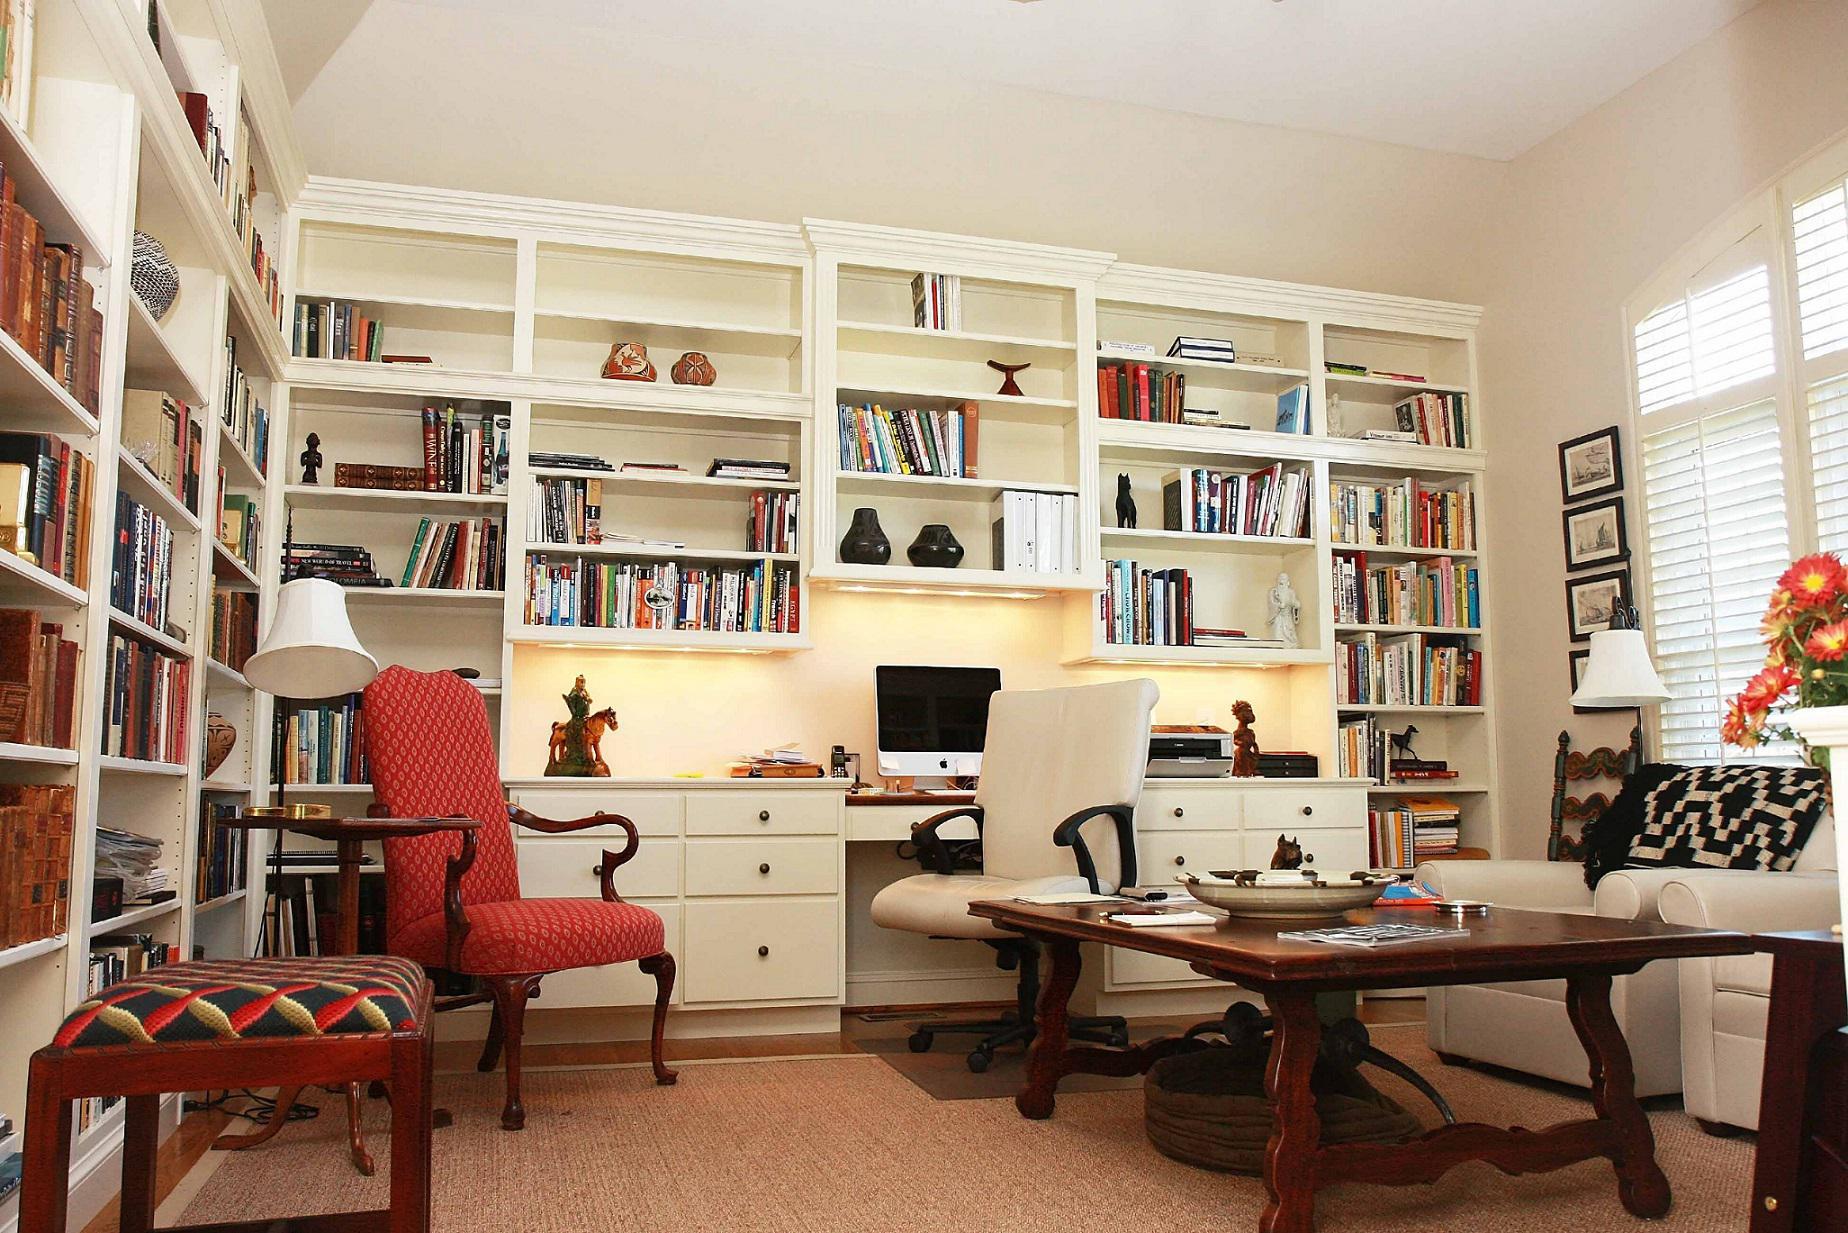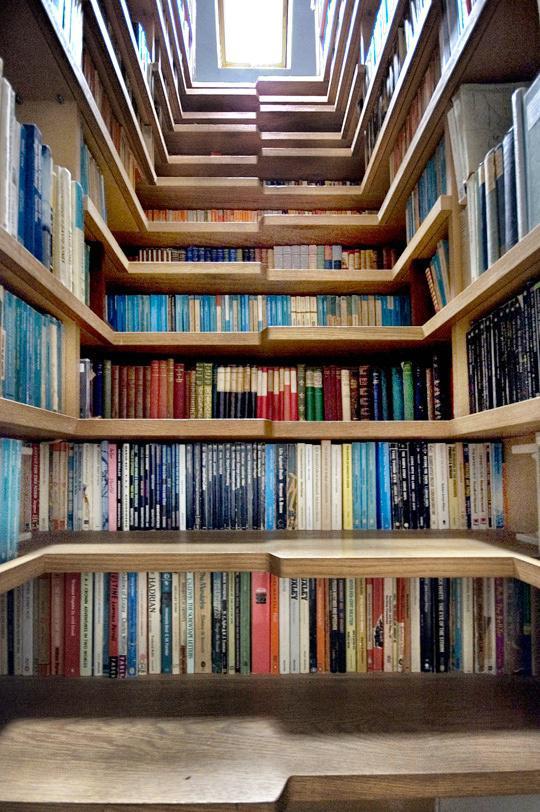The first image is the image on the left, the second image is the image on the right. Examine the images to the left and right. Is the description "One set of shelves has a built in window bench." accurate? Answer yes or no. No. 